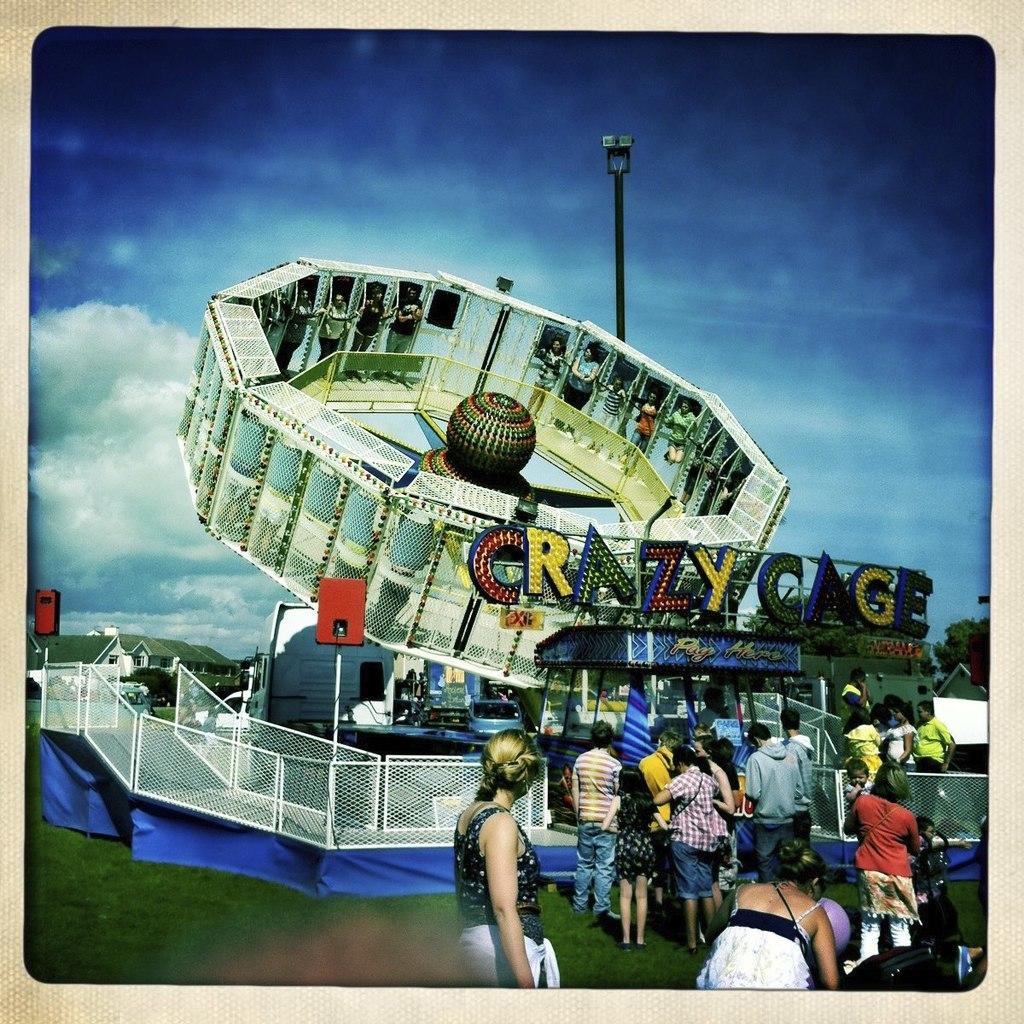In one or two sentences, can you explain what this image depicts? This image consists of a amusement ride. At the bottom, there is green grass. And we can see many people in this image. At the top, there are clouds in the sky. In the middle, there is a pole. 